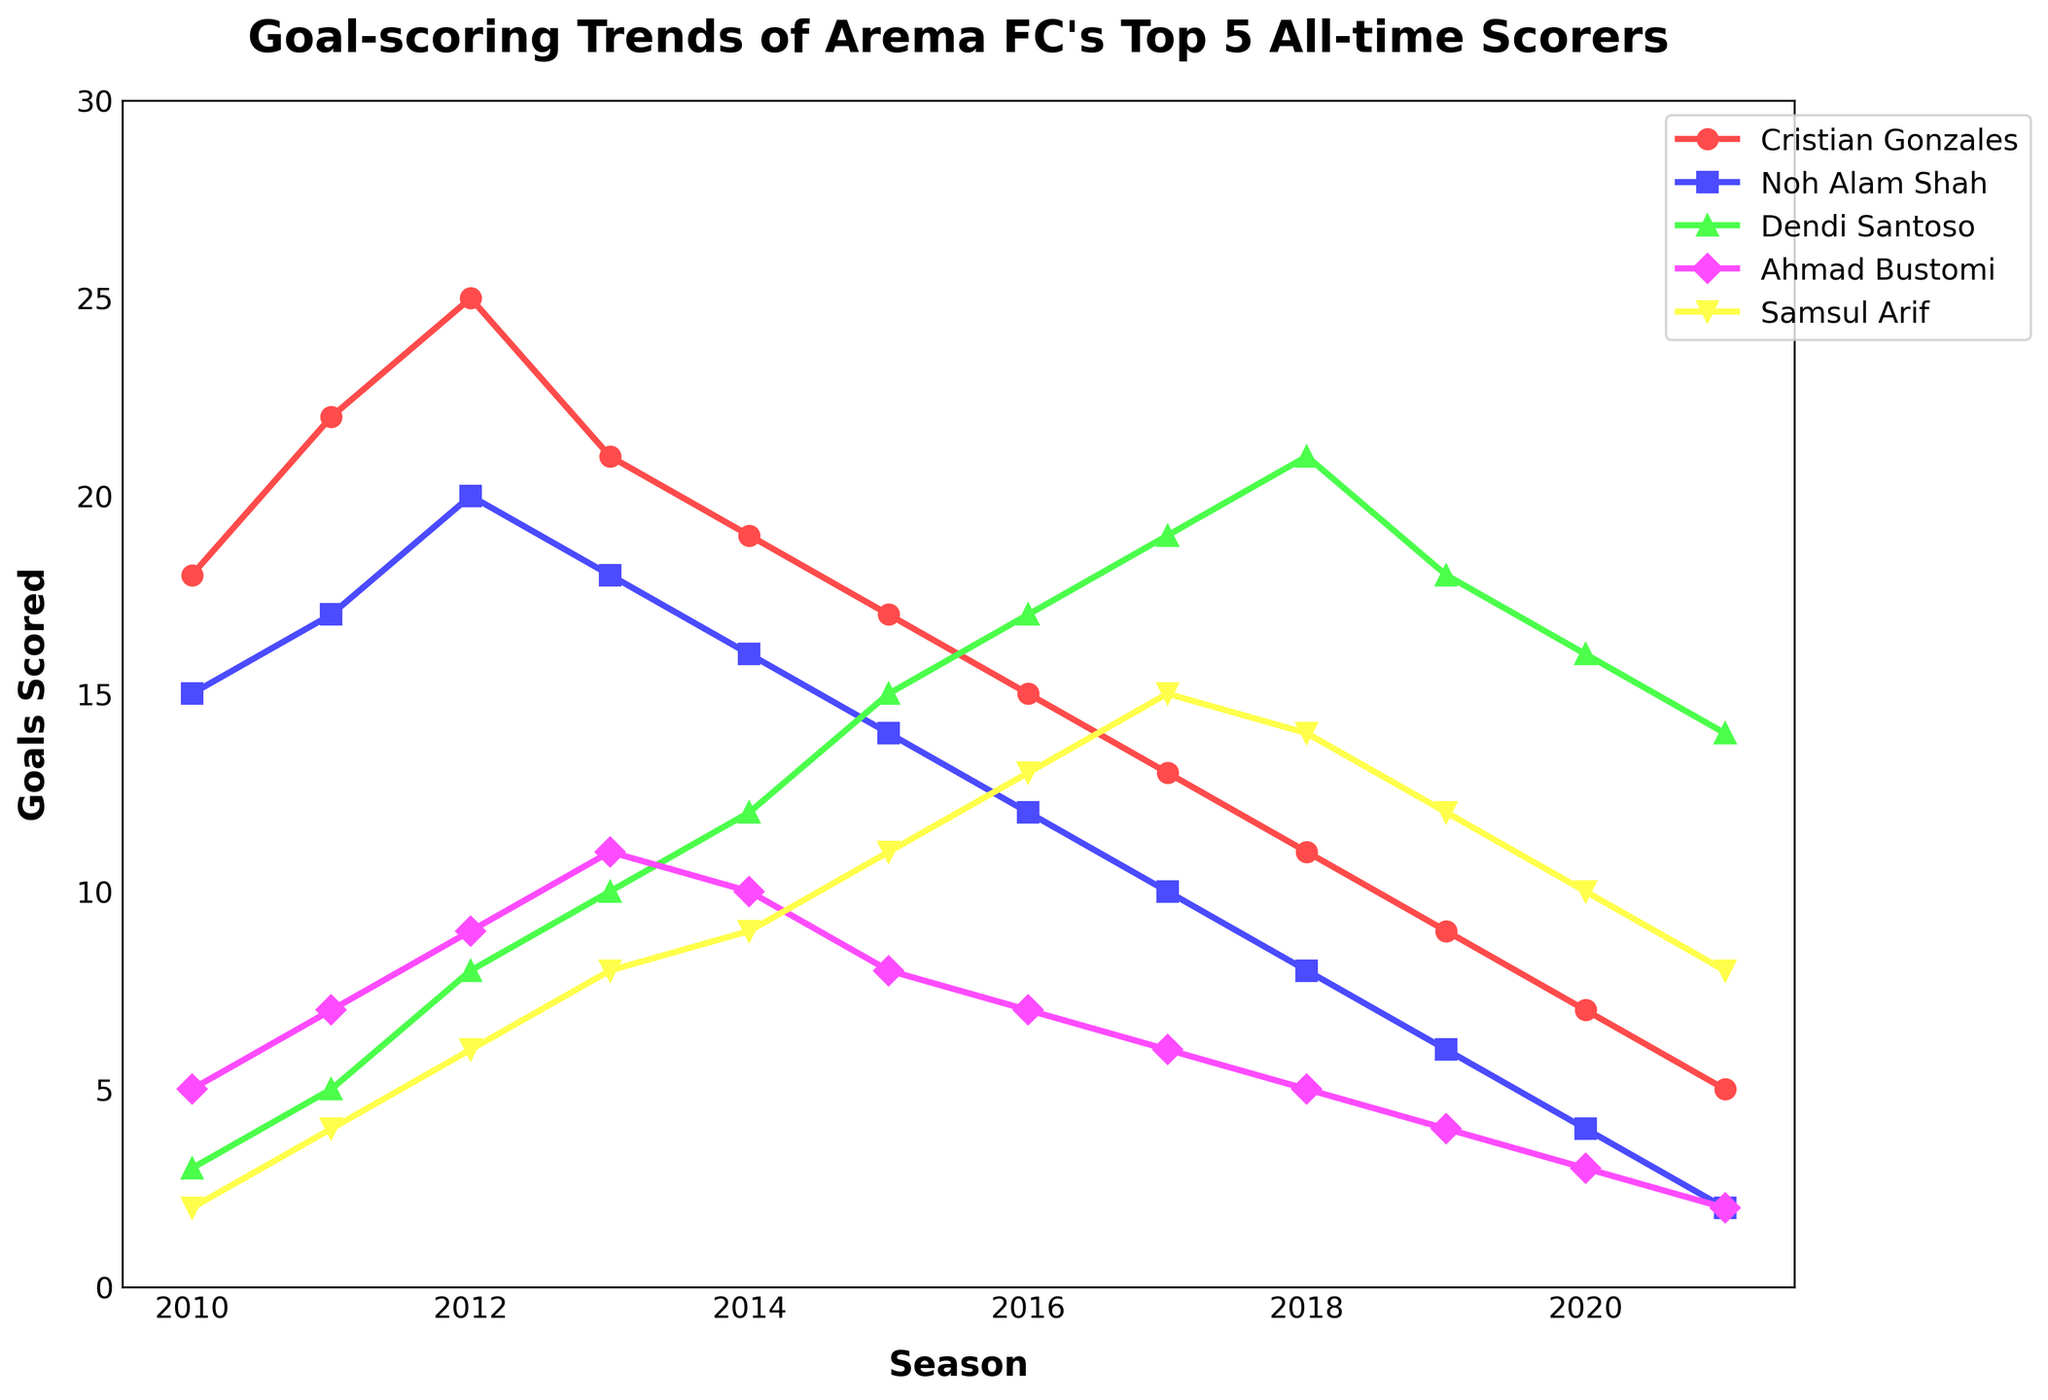When did Cristian Gonzales score the highest number of goals? To find the peak goal-scoring season for Cristian Gonzales, observe his line on the chart and identify the highest point. It is 2012, where the number of goals is 25.
Answer: 2012 In which season did Ahmad Bustomi score double-digit goals? Look at the values for Ahmad Bustomi across the seasons. The double-digit goals were achieved in 2012 (10) and 2013 (11).
Answer: 2012, 2013 How does Dendi Santoso's goals in 2016 compare with his goals in 2014? Compare the points on Dendi Santoso's line for 2016 and 2014. In 2016, he scored 17 goals, whereas in 2014, he scored 12 goals.
Answer: 2016 scored more Which player had the most consistent number of goals over the seasons? Consistency can be inferred by observing the player whose line has the least fluctuations. Ahmad Bustomi's line appears comparatively stable, staying between 2 and 11 goals.
Answer: Ahmad Bustomi During which season did Samsul Arif score the highest goal, and how many goals did he score that season? Look at Samsul Arif's line and identify the peak point. The highest goal count is in 2017, where he scored 15 goals.
Answer: 2017, 15 goals Which player's scoring trend shows a continuous decline from the beginning to the end of the data? Observe which player's line has a downward slope from start to end. Cristian Gonzales' line consistently declines from 2010 to 2021.
Answer: Cristian Gonzales How many goals did Noh Alam Shah score in 2015, and how does it compare to his 2012 goal count? Locate Noh Alam Shah's scores for 2015 (14 goals) and 2012 (20 goals) on the chart.
Answer: He scored 6 fewer goals in 2015 Which player scored the fewest goals in the 2020 season, and how many did he score? Identify the lowest point in 2020 among all players. Noh Alam Shah scored 4 goals.
Answer: Noh Alam Shah, 4 goals What's the difference in goals scored by Dendi Santoso between his highest and lowest scoring seasons? Identify Dendi Santoso's highest point at 21 goals in 2018 and lowest at 3 goals in 2010. The difference is 21 - 3 = 18 goals.
Answer: 18 goals 